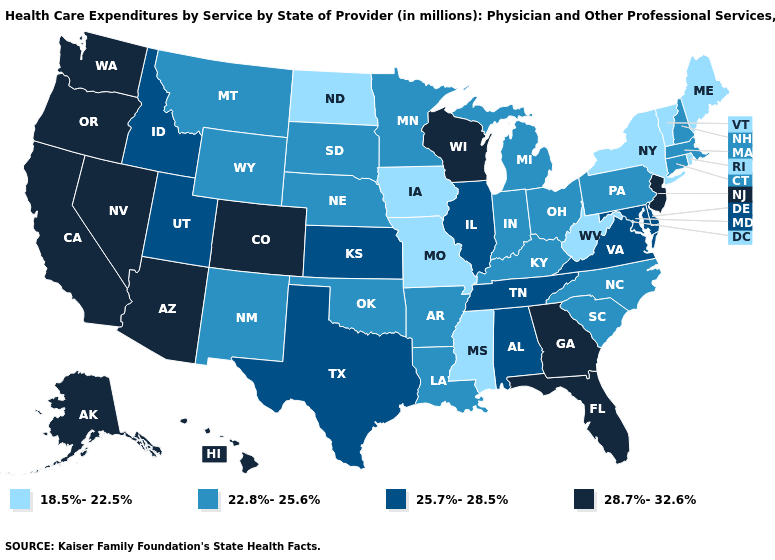Name the states that have a value in the range 28.7%-32.6%?
Be succinct. Alaska, Arizona, California, Colorado, Florida, Georgia, Hawaii, Nevada, New Jersey, Oregon, Washington, Wisconsin. Name the states that have a value in the range 18.5%-22.5%?
Be succinct. Iowa, Maine, Mississippi, Missouri, New York, North Dakota, Rhode Island, Vermont, West Virginia. What is the value of Louisiana?
Keep it brief. 22.8%-25.6%. What is the highest value in the MidWest ?
Be succinct. 28.7%-32.6%. Name the states that have a value in the range 22.8%-25.6%?
Write a very short answer. Arkansas, Connecticut, Indiana, Kentucky, Louisiana, Massachusetts, Michigan, Minnesota, Montana, Nebraska, New Hampshire, New Mexico, North Carolina, Ohio, Oklahoma, Pennsylvania, South Carolina, South Dakota, Wyoming. Name the states that have a value in the range 25.7%-28.5%?
Quick response, please. Alabama, Delaware, Idaho, Illinois, Kansas, Maryland, Tennessee, Texas, Utah, Virginia. Name the states that have a value in the range 18.5%-22.5%?
Answer briefly. Iowa, Maine, Mississippi, Missouri, New York, North Dakota, Rhode Island, Vermont, West Virginia. Which states have the highest value in the USA?
Be succinct. Alaska, Arizona, California, Colorado, Florida, Georgia, Hawaii, Nevada, New Jersey, Oregon, Washington, Wisconsin. What is the value of Rhode Island?
Short answer required. 18.5%-22.5%. What is the value of Tennessee?
Quick response, please. 25.7%-28.5%. What is the value of New York?
Concise answer only. 18.5%-22.5%. Name the states that have a value in the range 22.8%-25.6%?
Be succinct. Arkansas, Connecticut, Indiana, Kentucky, Louisiana, Massachusetts, Michigan, Minnesota, Montana, Nebraska, New Hampshire, New Mexico, North Carolina, Ohio, Oklahoma, Pennsylvania, South Carolina, South Dakota, Wyoming. Name the states that have a value in the range 18.5%-22.5%?
Be succinct. Iowa, Maine, Mississippi, Missouri, New York, North Dakota, Rhode Island, Vermont, West Virginia. Among the states that border Tennessee , which have the highest value?
Keep it brief. Georgia. What is the highest value in the USA?
Keep it brief. 28.7%-32.6%. 